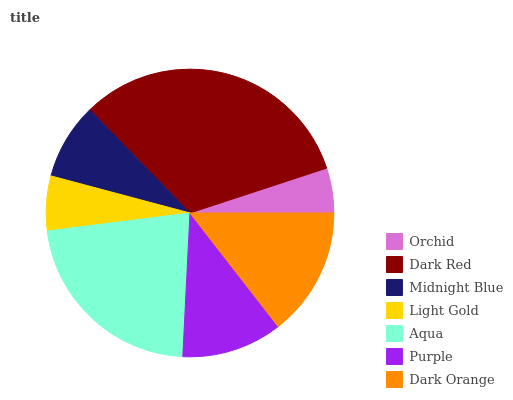Is Orchid the minimum?
Answer yes or no. Yes. Is Dark Red the maximum?
Answer yes or no. Yes. Is Midnight Blue the minimum?
Answer yes or no. No. Is Midnight Blue the maximum?
Answer yes or no. No. Is Dark Red greater than Midnight Blue?
Answer yes or no. Yes. Is Midnight Blue less than Dark Red?
Answer yes or no. Yes. Is Midnight Blue greater than Dark Red?
Answer yes or no. No. Is Dark Red less than Midnight Blue?
Answer yes or no. No. Is Purple the high median?
Answer yes or no. Yes. Is Purple the low median?
Answer yes or no. Yes. Is Dark Red the high median?
Answer yes or no. No. Is Midnight Blue the low median?
Answer yes or no. No. 